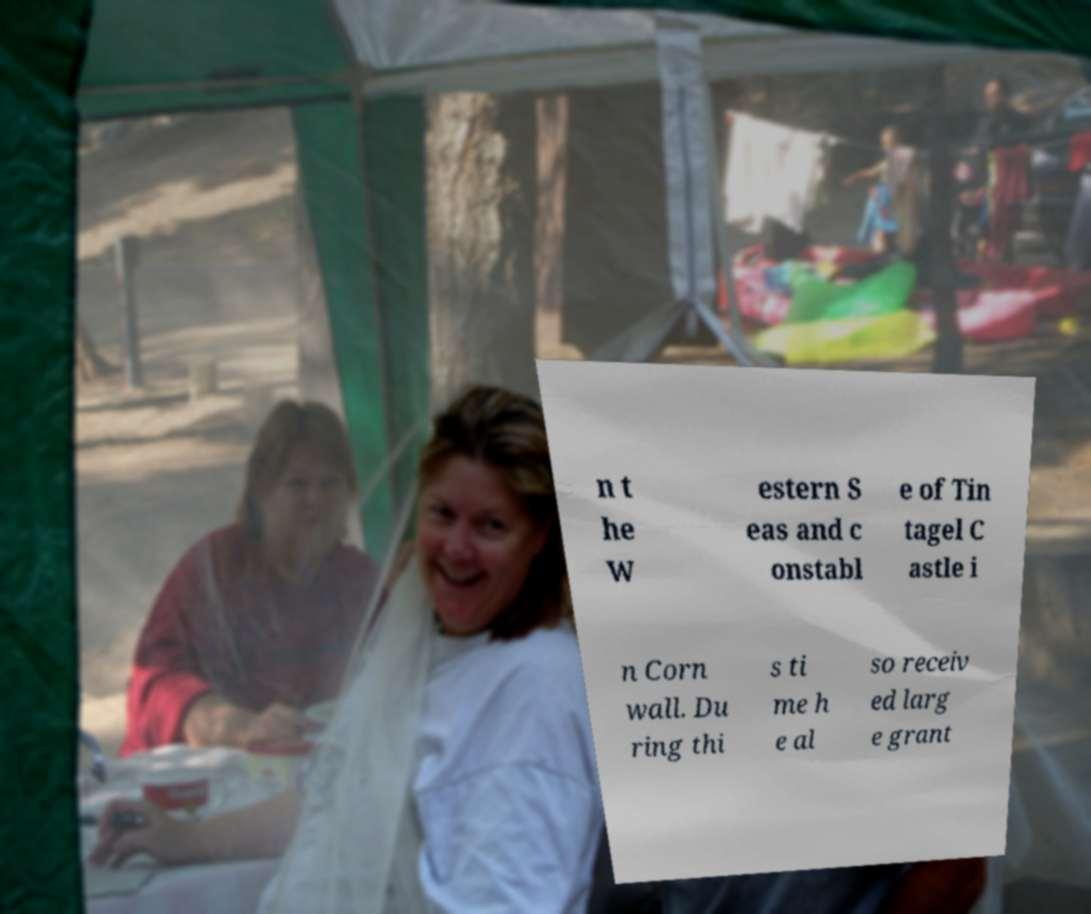Could you extract and type out the text from this image? n t he W estern S eas and c onstabl e of Tin tagel C astle i n Corn wall. Du ring thi s ti me h e al so receiv ed larg e grant 